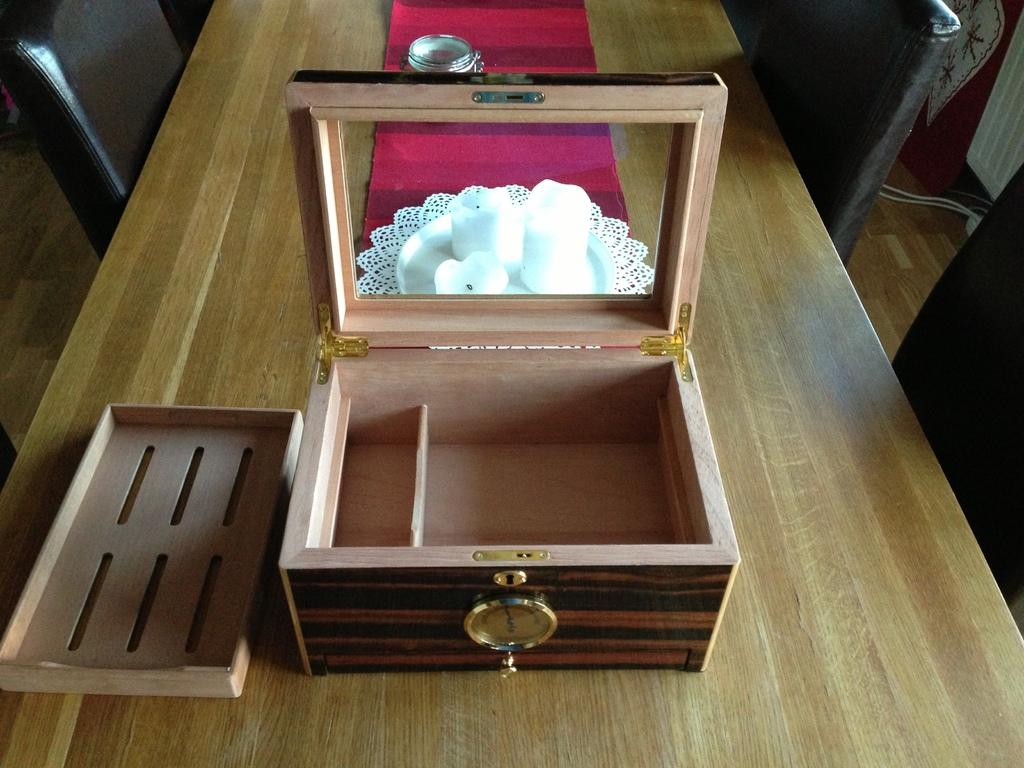What object is placed on the table in the image? There is a box on the table. What other items can be seen on the table? There are candles on the table. Is there any dishware present on the table? Yes, there is a plate on the table. What type of furniture is located beside the table? There are chairs beside the table. What type of island is visible in the background of the image? There is no island visible in the image; it only features a table with various objects on it and chairs beside it. 